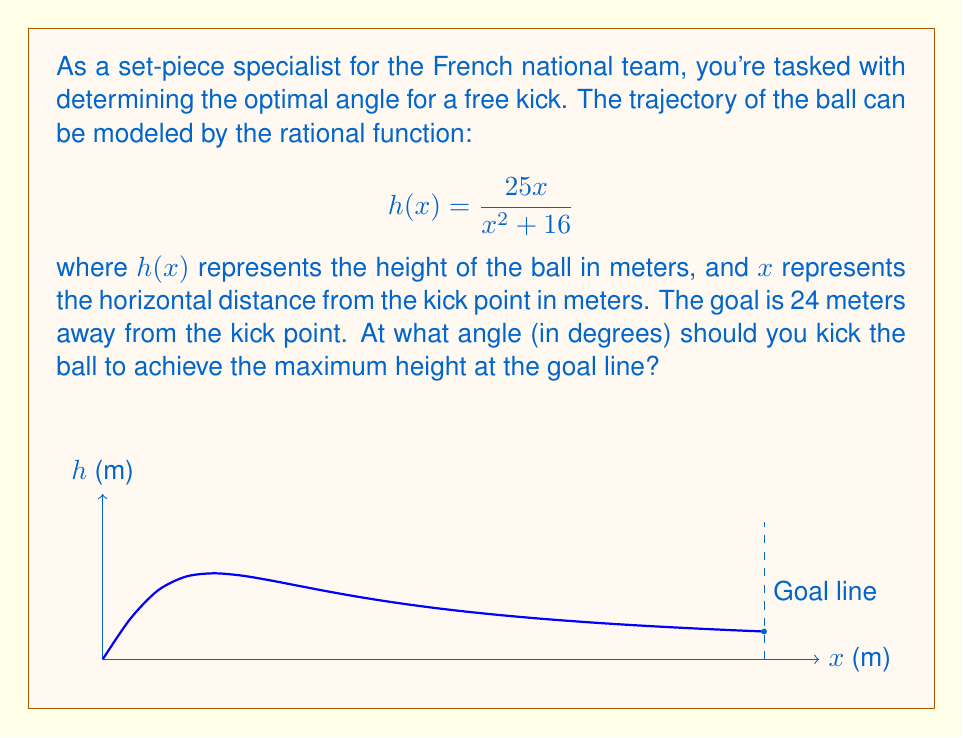Teach me how to tackle this problem. Let's approach this step-by-step:

1) To find the maximum height at the goal line, we need to calculate $h(24)$:

   $$h(24) = \frac{25(24)}{24^2 + 16} = \frac{600}{592} \approx 1.014 \text{ meters}$$

2) Now, we need to find the angle that corresponds to this height. We can use the tangent function:

   $$\tan(\theta) = \frac{\text{opposite}}{\text{adjacent}} = \frac{h(24)}{24} = \frac{600/592}{24} = \frac{25}{592}$$

3) To get the angle, we need to take the inverse tangent (arctan):

   $$\theta = \arctan\left(\frac{25}{592}\right)$$

4) Converting this to degrees:

   $$\theta = \arctan\left(\frac{25}{592}\right) \cdot \frac{180}{\pi} \approx 2.42°$$

Therefore, you should kick the ball at an angle of approximately 2.42° to achieve the maximum height at the goal line.
Answer: $2.42°$ 